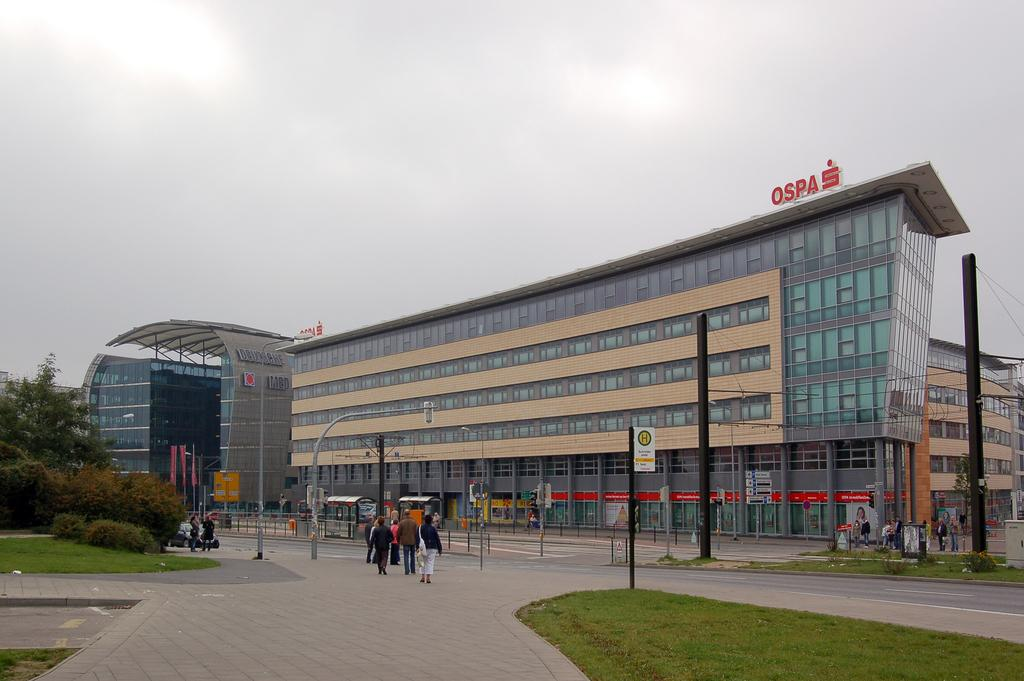What is located at the bottom of the image? At the bottom of the image, there are people, a road, walkways, grass, plants, trees, a vehicle, and poles. What can be seen in the background of the image? In the background of the image, there are buildings, walls, glass objects, boards, and the sky. What type of current is flowing through the hall in the image? There is no hall or current present in the image. What is the army doing in the image? There is no army or related activity depicted in the image. 